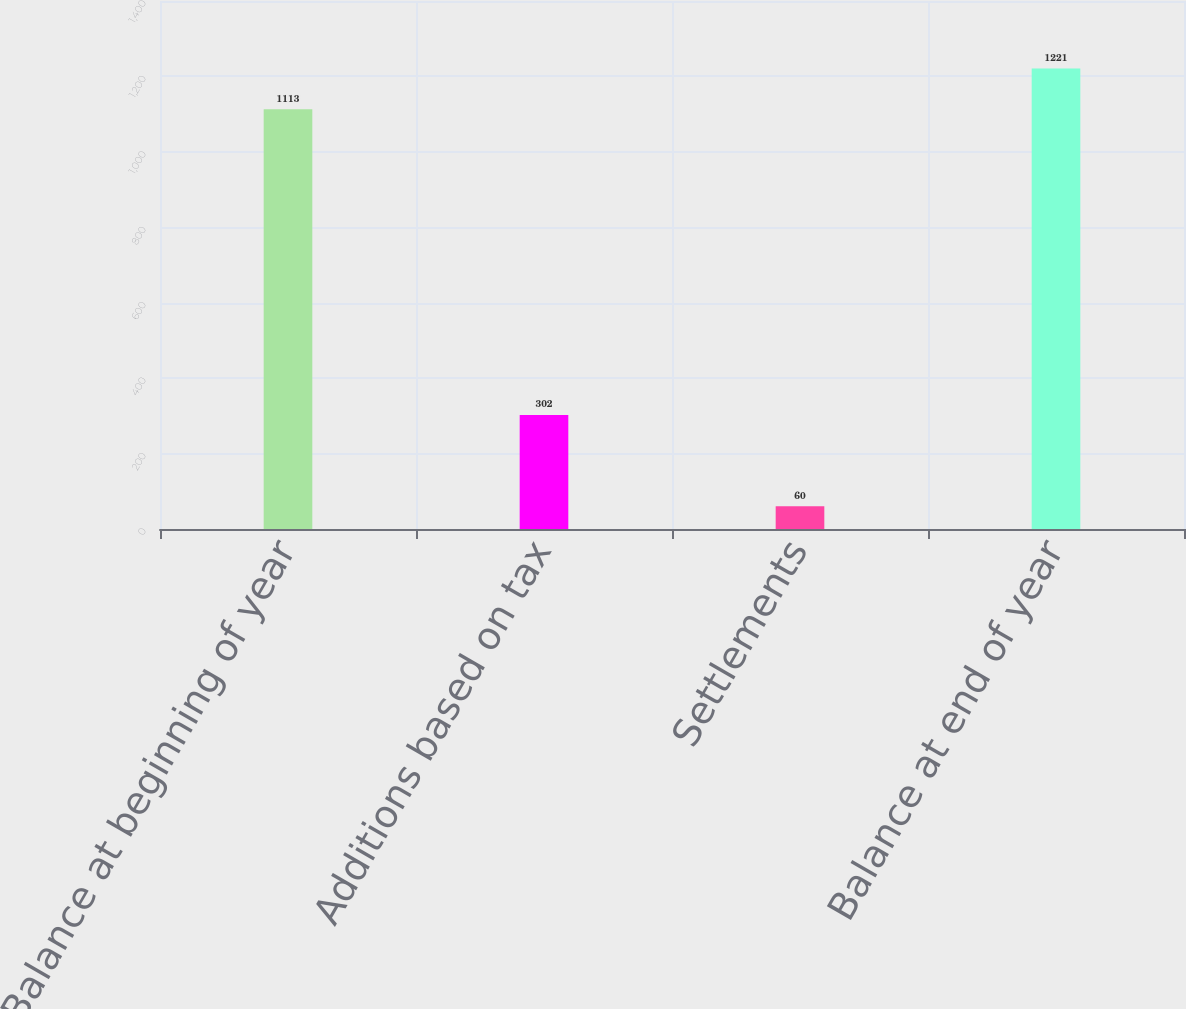<chart> <loc_0><loc_0><loc_500><loc_500><bar_chart><fcel>Balance at beginning of year<fcel>Additions based on tax<fcel>Settlements<fcel>Balance at end of year<nl><fcel>1113<fcel>302<fcel>60<fcel>1221<nl></chart> 